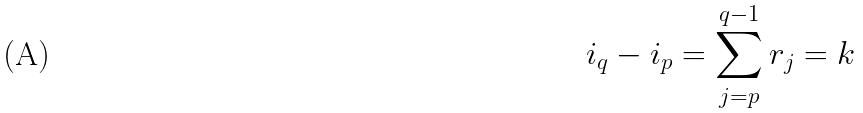<formula> <loc_0><loc_0><loc_500><loc_500>i _ { q } - i _ { p } = \sum _ { j = p } ^ { q - 1 } r _ { j } = k</formula> 